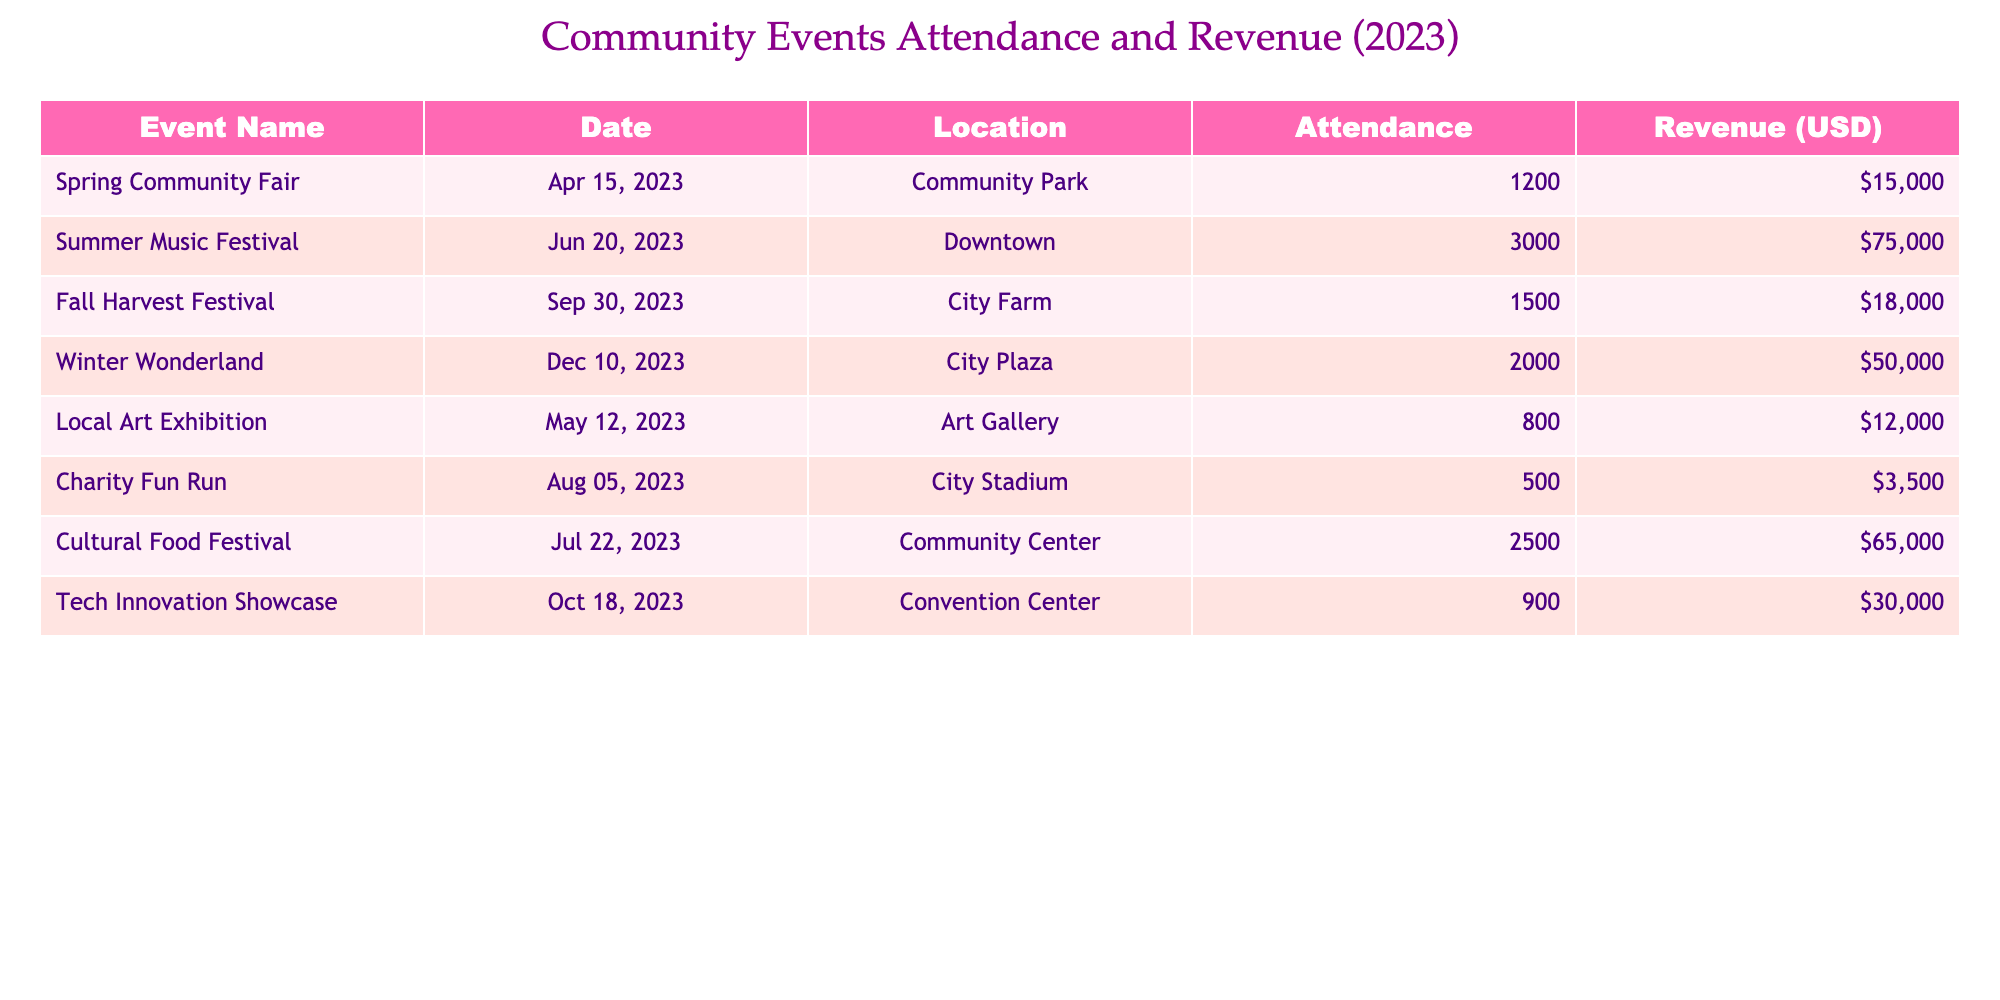What was the highest attendance at an event in 2023? The table lists the attendance for each event. The highest attendance is 3000 for the Summer Music Festival.
Answer: 3000 Which event generated the least revenue? By examining the revenue for each event, the Charity Fun Run has the lowest revenue at 3500 USD.
Answer: 3500 USD What is the total attendance across all events? To find the total attendance, I add all attendance numbers: 1200 + 3000 + 1500 + 2000 + 800 + 500 + 2500 + 900 = 11500.
Answer: 11500 What was the average revenue of the events held in 2023? First, I sum the revenue: 15000 + 75000 + 18000 + 50000 + 12000 + 3500 + 65000 + 30000 = 200500. There are 8 events, so average revenue is 200500 / 8 = 25062.5 USD.
Answer: 25062.5 USD Did the Fall Harvest Festival have more attendance than the Spring Community Fair? The Fall Harvest Festival had an attendance of 1500, while the Spring Community Fair had 1200. Since 1500 is greater than 1200, the answer is yes.
Answer: Yes Which event happened closest to the end of the year? The events are listed by date. The latest date is December 10, 2023, corresponding to the Winter Wonderland event.
Answer: Winter Wonderland What percentage of the total revenue was generated by the Summer Music Festival? First, the revenue for the Summer Music Festival is 75000 USD. I already calculated the total revenue as 200500 USD. The percentage is (75000 / 200500) * 100 = 37.4%.
Answer: 37.4% Is it true that the Cultural Food Festival had more attendance than the Local Art Exhibition? The Cultural Food Festival had 2500 attendees, while the Local Art Exhibition had 800 attendees. Since 2500 is greater than 800, the answer is yes.
Answer: Yes What is the difference in attendance between the Winter Wonderland and the Charity Fun Run? The Winter Wonderland had 2000 attendees, while the Charity Fun Run had 500. The difference is 2000 - 500 = 1500.
Answer: 1500 